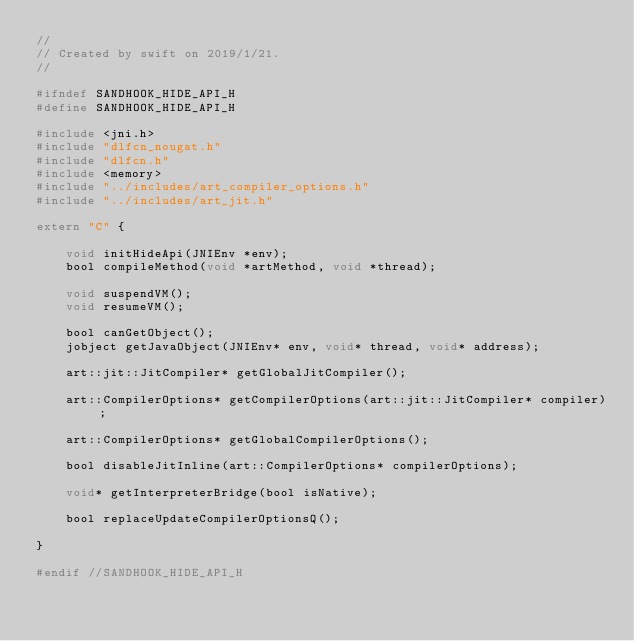Convert code to text. <code><loc_0><loc_0><loc_500><loc_500><_C_>//
// Created by swift on 2019/1/21.
//

#ifndef SANDHOOK_HIDE_API_H
#define SANDHOOK_HIDE_API_H

#include <jni.h>
#include "dlfcn_nougat.h"
#include "dlfcn.h"
#include <memory>
#include "../includes/art_compiler_options.h"
#include "../includes/art_jit.h"

extern "C" {

    void initHideApi(JNIEnv *env);
    bool compileMethod(void *artMethod, void *thread);

    void suspendVM();
    void resumeVM();

    bool canGetObject();
    jobject getJavaObject(JNIEnv* env, void* thread, void* address);

    art::jit::JitCompiler* getGlobalJitCompiler();

    art::CompilerOptions* getCompilerOptions(art::jit::JitCompiler* compiler);

    art::CompilerOptions* getGlobalCompilerOptions();

    bool disableJitInline(art::CompilerOptions* compilerOptions);

    void* getInterpreterBridge(bool isNative);

    bool replaceUpdateCompilerOptionsQ();

}

#endif //SANDHOOK_HIDE_API_H
</code> 